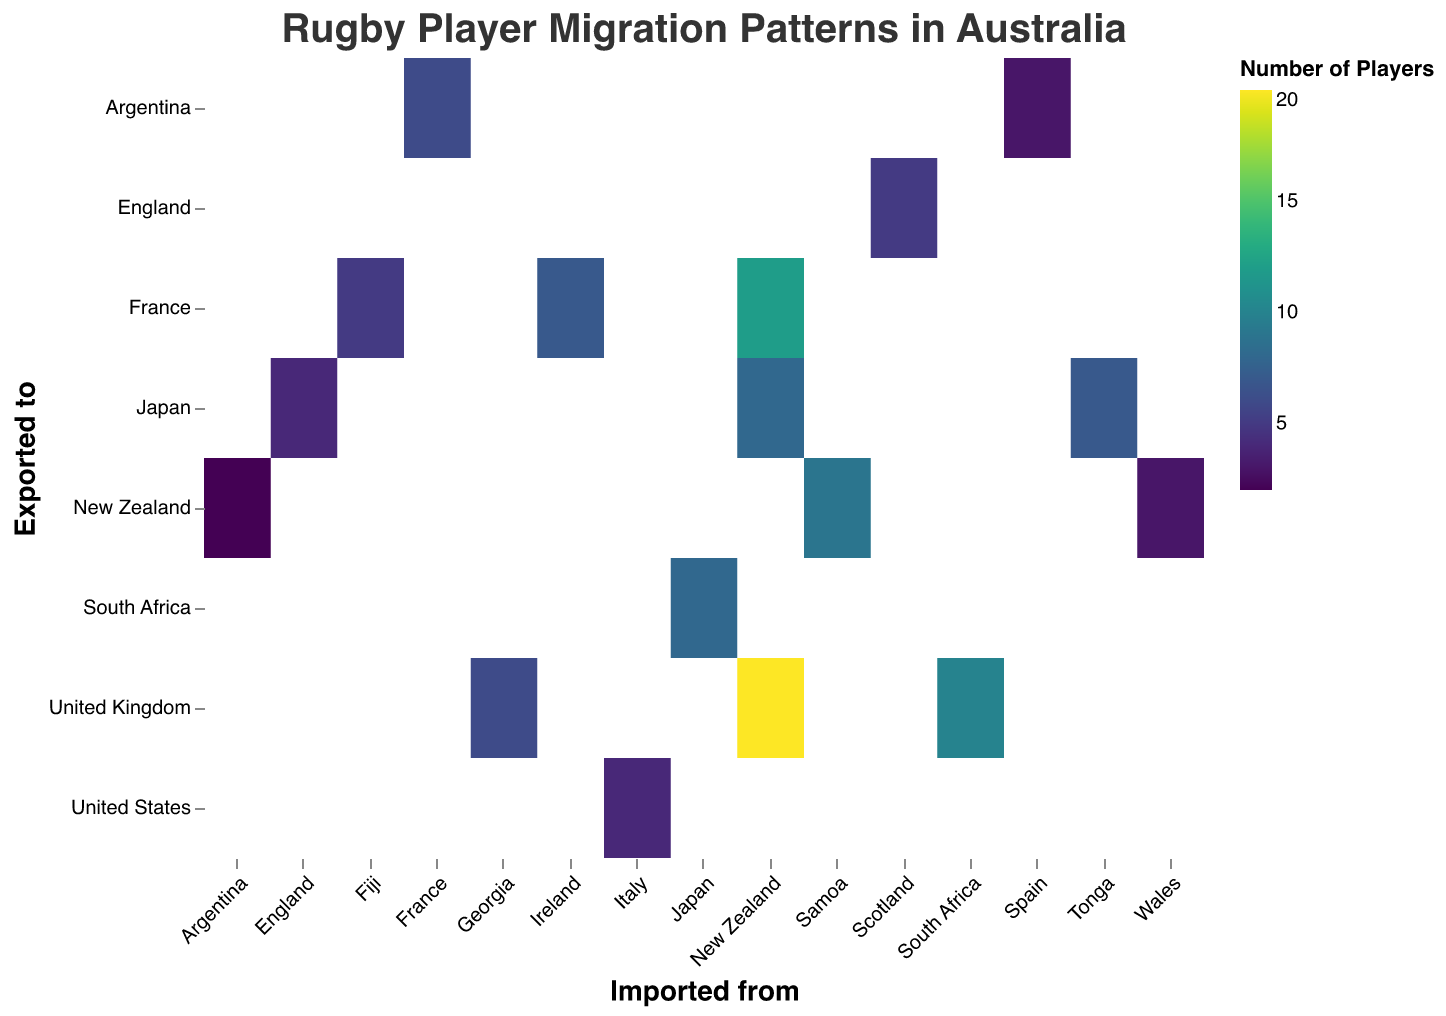What's the title of the heatmap? The title is located at the top of the heatmap and is explicitly written.
Answer: Rugby Player Migration Patterns in Australia From which country does Australia import the highest number of rugby players? By looking at the color intensity on the horizontal axis labeled "Imported from," the darkest rectangle represents the highest value.
Answer: New Zealand Which country has the highest number of rugby players exported from Australia to the United Kingdom? Look at the "Exported to" column labeled "United Kingdom" and identify the darkest rectangle.
Answer: New Zealand How many players were exported from Australia to France from Ireland? Locate the intersection between Ireland on the "Imported from" axis and France on the "Exported to" axis and check the number displayed.
Answer: 7 What is the sum of players exported from Australia to Japan from New Zealand and Tonga? Locate the intersections from both New Zealand and Tonga rows with Japan in the "Exported to" axis and sum up their values: 8 (New Zealand) + 7 (Tonga).
Answer: 15 Which imported country also exports players to Argentina according to this dataset? Look for the rows intersecting with Argentina on the "Exported to" axis and note down the countries listed on "Imported from" axis.
Answer: France and Spain How many players in total have been exported from Australia to New Zealand? Sum the count of players from all "Imported from" categories intersecting with New Zealand in the "Exported to" row: Samoa (9) + Wales (3) + Argentina (2).
Answer: 14 How does the number of players imported from Georgia and exported to the United Kingdom compare to those imported from South Africa and exported to the same destination? Compare the counts for Georgia (6) and South Africa (10) in the intersections with the United Kingdom on the "Exported to" axis.
Answer: South Africa has more (6 vs. 10) What is the average number of players imported from New Zealand and exported to various countries? List and sum the counts, then divide by the number of countries: United Kingdom (20) + France (12) + Japan (8), Total = 40 / 3.
Answer: 13.33 Which destination has the least number of players exported from Australia and imported from Tonga? Check the intersections for Tonga in the "Imported from" row and identify the lowest value on the "Exported to" column.
Answer: Japan 